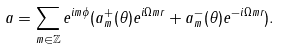<formula> <loc_0><loc_0><loc_500><loc_500>a = \sum _ { m \in \mathbb { Z } } e ^ { i m \phi } ( a _ { m } ^ { + } ( \theta ) e ^ { i \Omega m r } + a _ { m } ^ { - } ( \theta ) e ^ { - i \Omega m r } ) .</formula> 